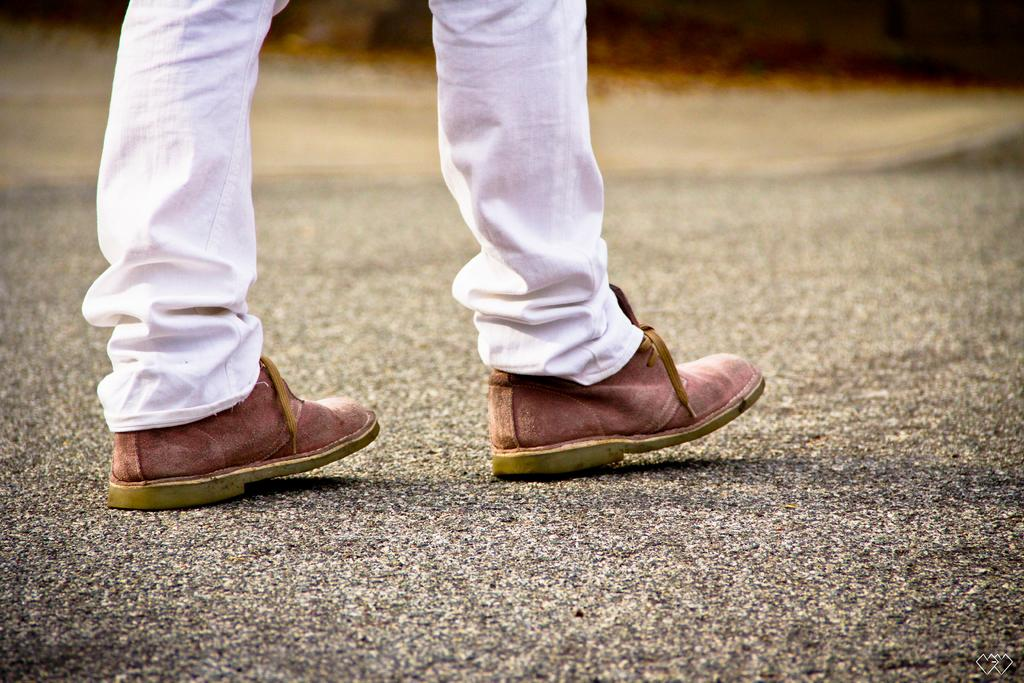What is the main subject of the image? The main subject of the image is a person's legs. Can you describe the background of the image? There is a road in the background in the background of the image. What type of berry can be seen growing on the side of the road in the image? There is no berry visible in the image; the main subject is a person's legs, and the background features a road. 